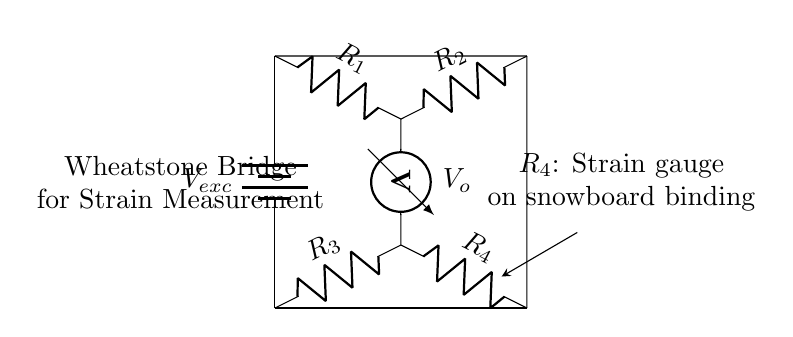What is the purpose of the component labeled R4? R4 is a strain gauge located on the snowboard binding, which is used to measure strain by detecting resistance changes associated with deformation when pressure is applied.
Answer: Strain gauge What type of circuit is depicted in the diagram? The circuit is a Wheatstone Bridge, characterized by its arrangement of resistors that allows for precise measurement of voltage differences and changes in resistance, often used for sensing applications like strain measurement.
Answer: Wheatstone Bridge What is the voltage source in this circuit? The voltage source is indicated as Vexc, which provides the necessary voltage to power the circuit and establish a potential difference across the resistors for measurement purposes.
Answer: Vexc How many resistors are present in this Wheatstone Bridge? There are four resistors in the circuit, denoted as R1, R2, R3, and R4, arranged in a way that allows for balanced measurement of voltage differences when strain occurs.
Answer: Four Which voltmeter is used to measure the potential difference? The voltmeter is connected between the nodes that contain R2 and R3, measuring Vo, which indicates the potential difference across these two resistors and helps in determining the strain applied by measuring resistance variations.
Answer: Vo What happens to the voltage output VO when R4 changes due to strain? When R4 changes in response to strain (due to force applied on the snowboard binding), VO will reflect this change in resistance, shifting the balance of the bridge and indicating the amount of strain through the voltage differential across the bridge.
Answer: Changes proportionately 